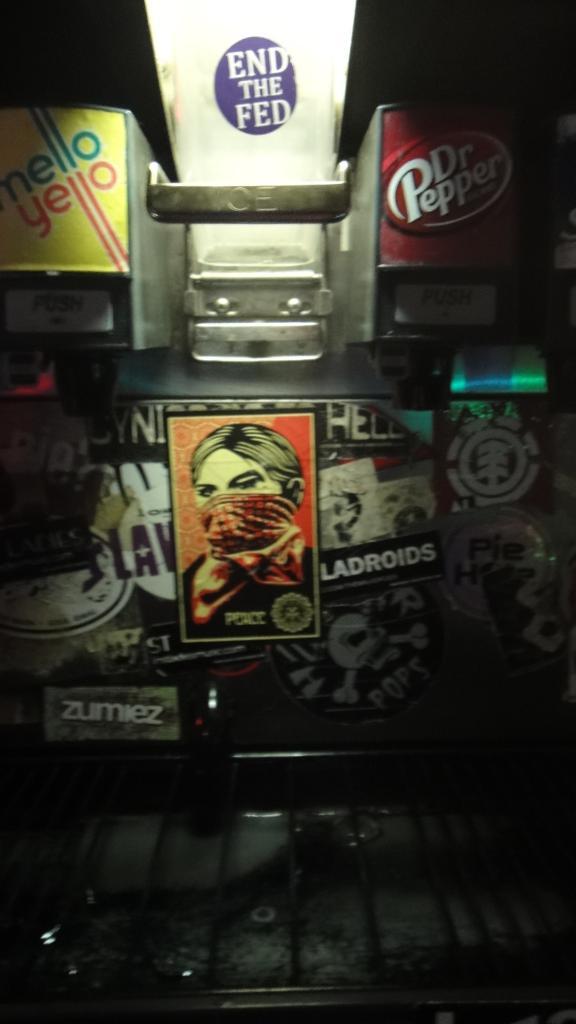What brand has the red advertisement?
Offer a very short reply. Dr pepper. Is there a brand of soda is advertised?
Give a very brief answer. Yes. 